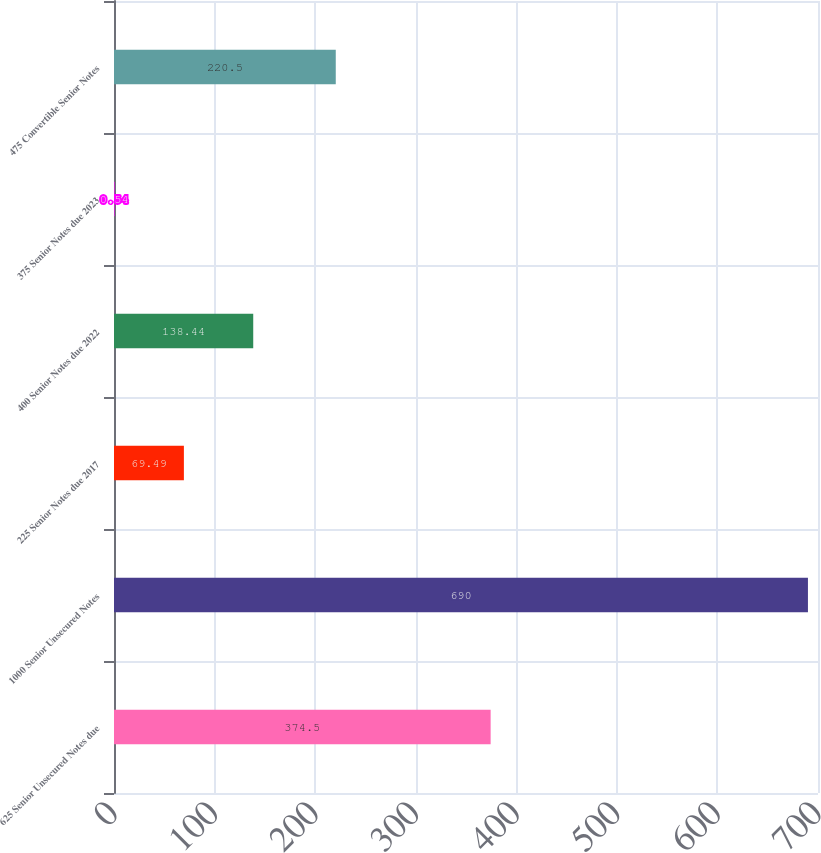Convert chart. <chart><loc_0><loc_0><loc_500><loc_500><bar_chart><fcel>625 Senior Unsecured Notes due<fcel>1000 Senior Unsecured Notes<fcel>225 Senior Notes due 2017<fcel>400 Senior Notes due 2022<fcel>375 Senior Notes due 2023<fcel>475 Convertible Senior Notes<nl><fcel>374.5<fcel>690<fcel>69.49<fcel>138.44<fcel>0.54<fcel>220.5<nl></chart> 